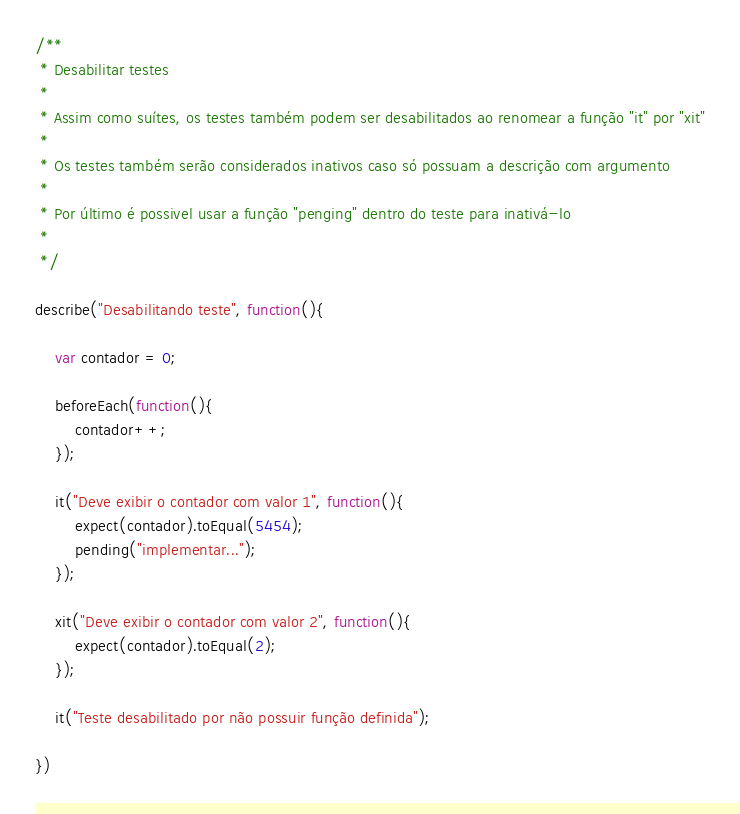Convert code to text. <code><loc_0><loc_0><loc_500><loc_500><_JavaScript_>/**
 * Desabilitar testes
 * 
 * Assim como suítes, os testes também podem ser desabilitados ao renomear a função "it" por "xit"
 * 
 * Os testes também serão considerados inativos caso só possuam a descrição com argumento
 * 
 * Por último é possivel usar a função "penging" dentro do teste para inativá-lo
 * 
 */

describe("Desabilitando teste", function(){

    var contador = 0;

    beforeEach(function(){
        contador++;
    });

    it("Deve exibir o contador com valor 1", function(){
        expect(contador).toEqual(5454);
        pending("implementar...");
    });

    xit("Deve exibir o contador com valor 2", function(){
        expect(contador).toEqual(2);
    });

    it("Teste desabilitado por não possuir função definida");

})</code> 